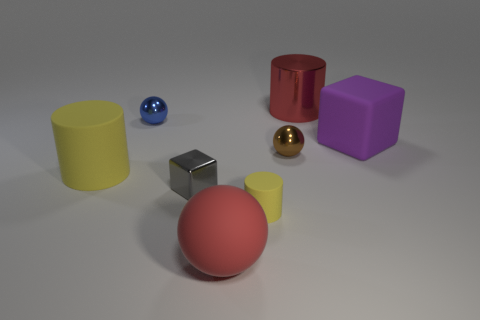Are there any tiny gray metallic objects that have the same shape as the big purple matte thing?
Provide a short and direct response. Yes. What material is the thing that is the same color as the large shiny cylinder?
Your answer should be compact. Rubber. What number of objects are either tiny yellow metal cylinders or matte objects that are on the left side of the purple thing?
Your answer should be very brief. 3. There is a gray thing that is the same size as the brown sphere; what is it made of?
Your answer should be very brief. Metal. Does the small brown sphere have the same material as the big yellow cylinder?
Provide a succinct answer. No. What color is the matte thing that is behind the gray metallic cube and on the left side of the tiny yellow object?
Provide a succinct answer. Yellow. There is a large cylinder to the left of the brown metallic object; is it the same color as the tiny matte thing?
Your answer should be very brief. Yes. What shape is the purple matte thing that is the same size as the red metallic cylinder?
Provide a short and direct response. Cube. What number of other things are the same color as the big matte block?
Offer a very short reply. 0. How many other things are made of the same material as the blue thing?
Your response must be concise. 3. 